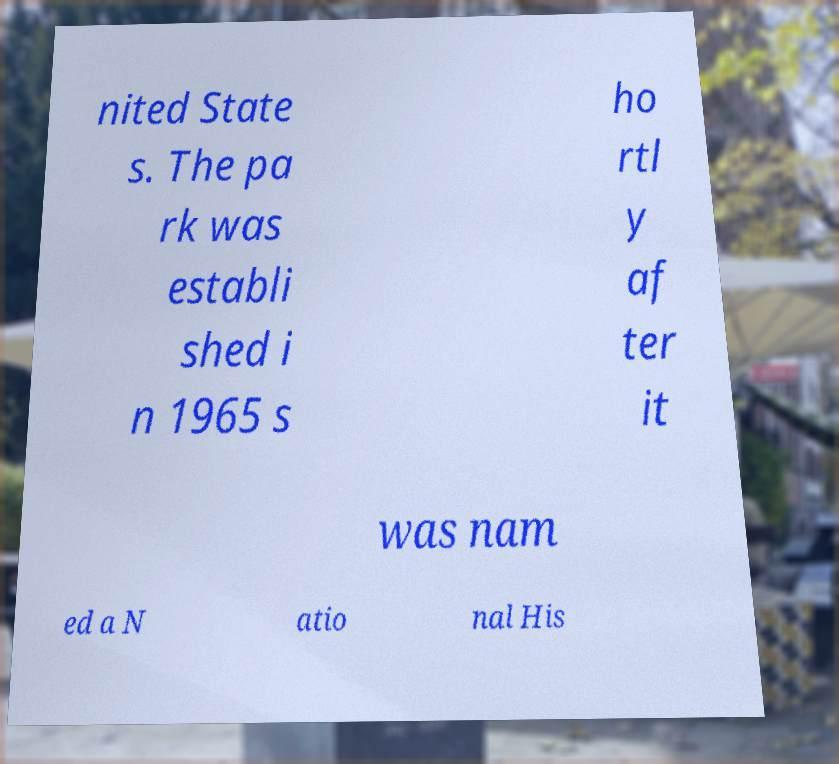For documentation purposes, I need the text within this image transcribed. Could you provide that? nited State s. The pa rk was establi shed i n 1965 s ho rtl y af ter it was nam ed a N atio nal His 